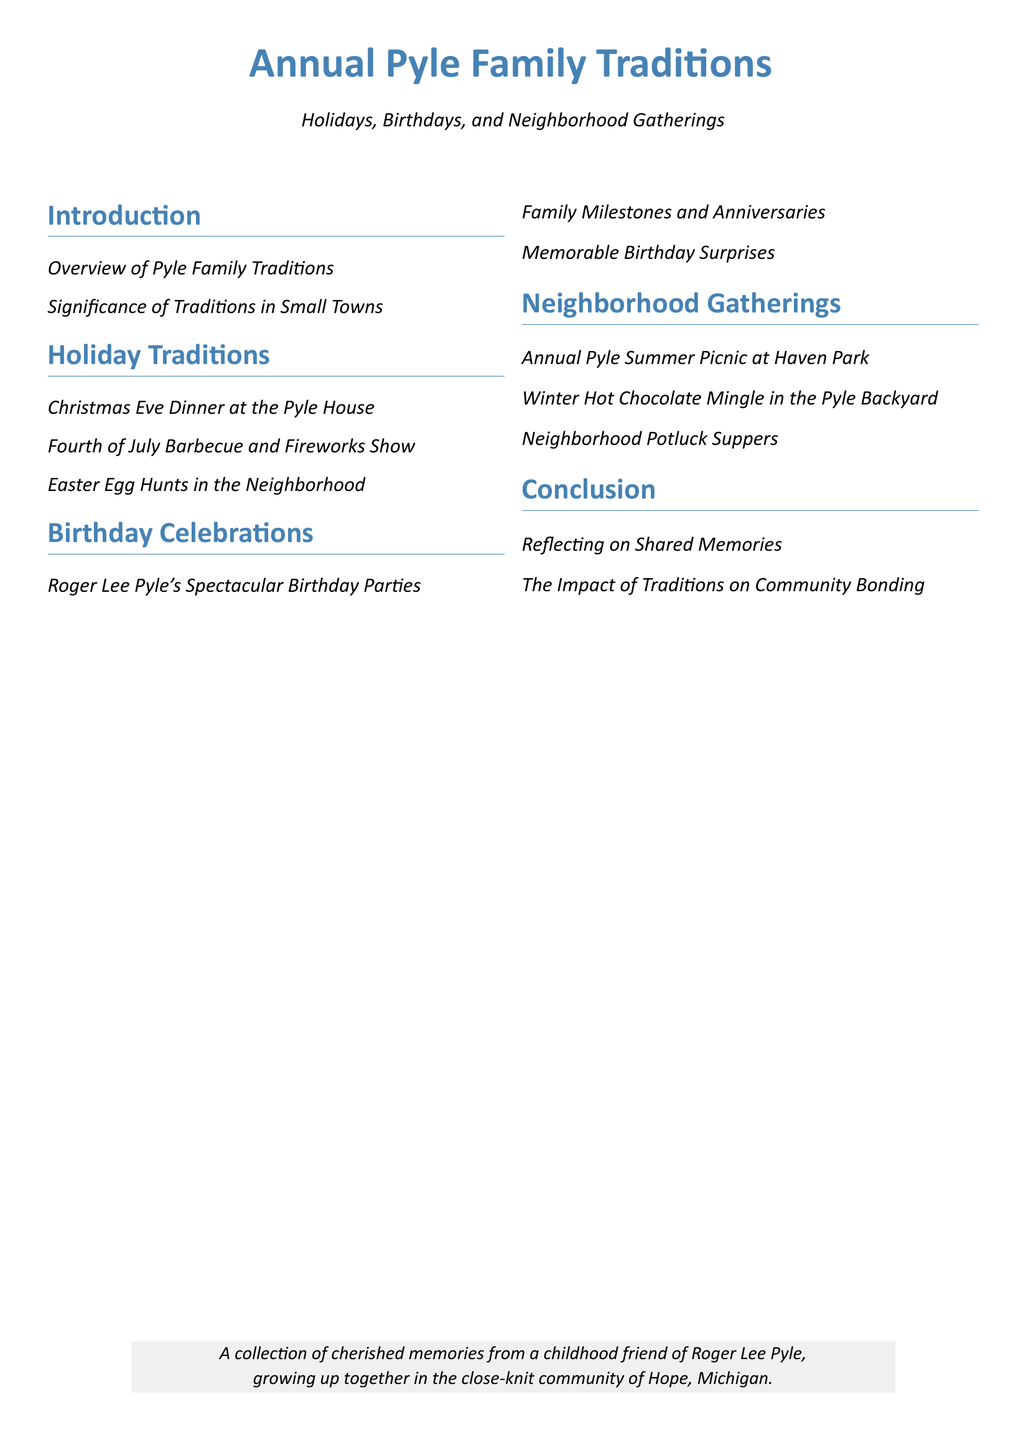What is the title of the document? The title of the document is the main heading found at the top of the table of contents.
Answer: Annual Pyle Family Traditions What is the color used for headings? The document specifies a color name associated with the headings in the table of contents.
Answer: Pyle Blue What event is celebrated with a barbecue? The document lists a specific holiday where a particular gathering takes place.
Answer: Fourth of July Barbecue How many sections are in the document? The sections of the document are counted as defined in the table of contents.
Answer: Five What is one type of neighborhood gathering mentioned? The document specifies a particular gathering that occurs in the neighborhood.
Answer: Annual Pyle Summer Picnic What is the significance of traditions according to the document? The document describes an important aspect relating to traditions in communities.
Answer: Community Bonding What type of document is this? The document's structure and purpose indicate its classification in literature.
Answer: Table of Contents What is one memorable event related to Roger Lee Pyle? The document recalls a specific type of celebration that features Roger Lee Pyle.
Answer: Spectacular Birthday Parties 